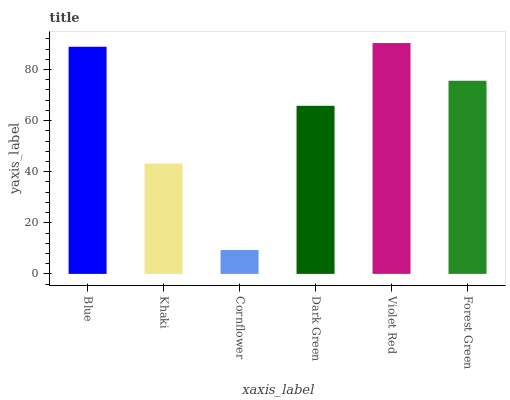Is Cornflower the minimum?
Answer yes or no. Yes. Is Violet Red the maximum?
Answer yes or no. Yes. Is Khaki the minimum?
Answer yes or no. No. Is Khaki the maximum?
Answer yes or no. No. Is Blue greater than Khaki?
Answer yes or no. Yes. Is Khaki less than Blue?
Answer yes or no. Yes. Is Khaki greater than Blue?
Answer yes or no. No. Is Blue less than Khaki?
Answer yes or no. No. Is Forest Green the high median?
Answer yes or no. Yes. Is Dark Green the low median?
Answer yes or no. Yes. Is Dark Green the high median?
Answer yes or no. No. Is Khaki the low median?
Answer yes or no. No. 